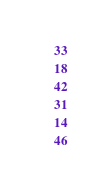Convert code to text. <code><loc_0><loc_0><loc_500><loc_500><_Python_>    33
    18
    42
    31
    14
    46</code> 